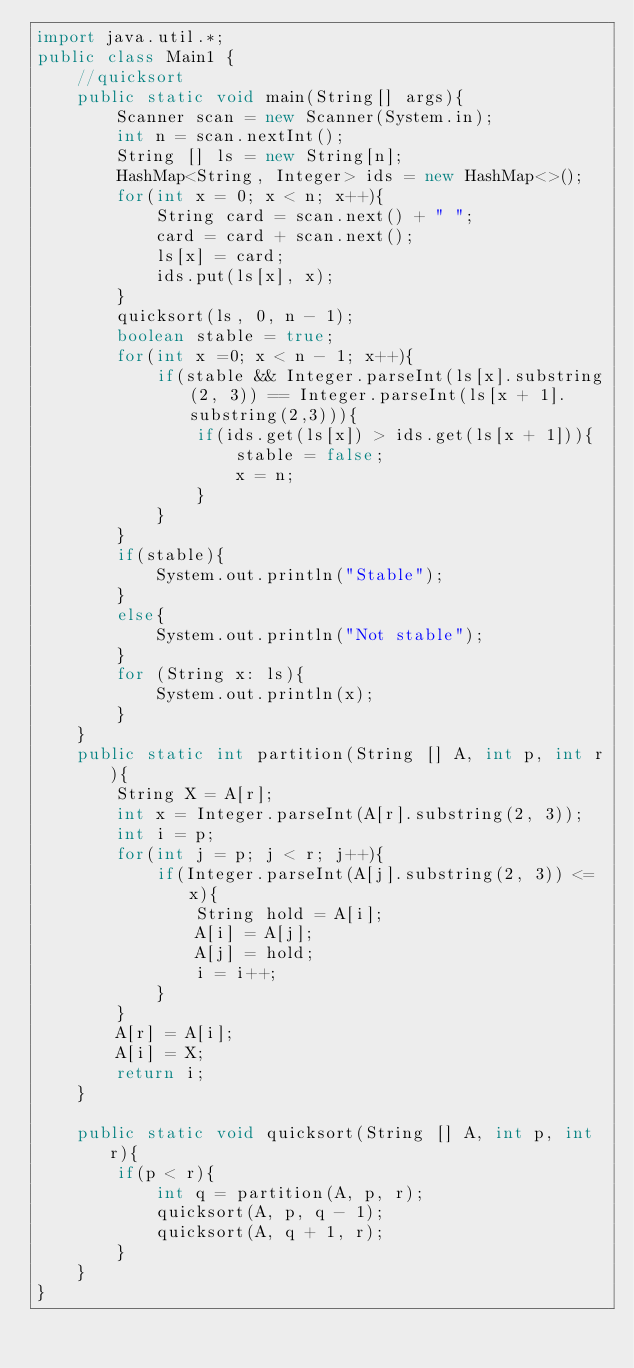<code> <loc_0><loc_0><loc_500><loc_500><_Java_>import java.util.*;
public class Main1 {
    //quicksort
    public static void main(String[] args){
        Scanner scan = new Scanner(System.in);
        int n = scan.nextInt();
        String [] ls = new String[n];
        HashMap<String, Integer> ids = new HashMap<>();
        for(int x = 0; x < n; x++){
            String card = scan.next() + " ";
            card = card + scan.next();
            ls[x] = card;
            ids.put(ls[x], x);
        }
        quicksort(ls, 0, n - 1);
        boolean stable = true;
        for(int x =0; x < n - 1; x++){
            if(stable && Integer.parseInt(ls[x].substring(2, 3)) == Integer.parseInt(ls[x + 1].substring(2,3))){
                if(ids.get(ls[x]) > ids.get(ls[x + 1])){
                    stable = false;
                    x = n;
                }
            }
        }
        if(stable){
            System.out.println("Stable");
        }
        else{
            System.out.println("Not stable");
        }
        for (String x: ls){
            System.out.println(x);
        }
    }
    public static int partition(String [] A, int p, int r){
        String X = A[r];
        int x = Integer.parseInt(A[r].substring(2, 3));
        int i = p;
        for(int j = p; j < r; j++){
            if(Integer.parseInt(A[j].substring(2, 3)) <= x){
                String hold = A[i];
                A[i] = A[j];
                A[j] = hold;
                i = i++;
            }
        }
        A[r] = A[i];
        A[i] = X;
        return i;
    }

    public static void quicksort(String [] A, int p, int r){
        if(p < r){
            int q = partition(A, p, r);
            quicksort(A, p, q - 1);
            quicksort(A, q + 1, r);
        }
    }
}
</code> 